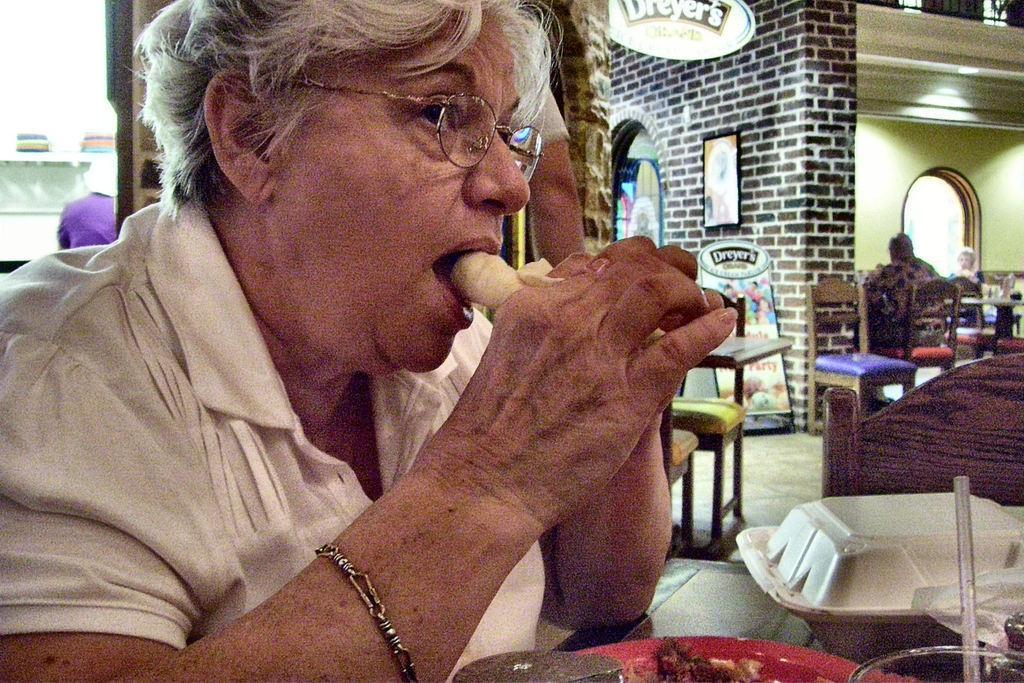How would you summarize this image in a sentence or two? In this image in the foreground there is one person who is sitting and she is eating something, in front of her there is one table. On the table there is one plate, glass and some objects. In the background there are some chairs and one person is sitting on a chair and also there is a wall. On the wall there are some photo frames and also we could see some boards and lights. 